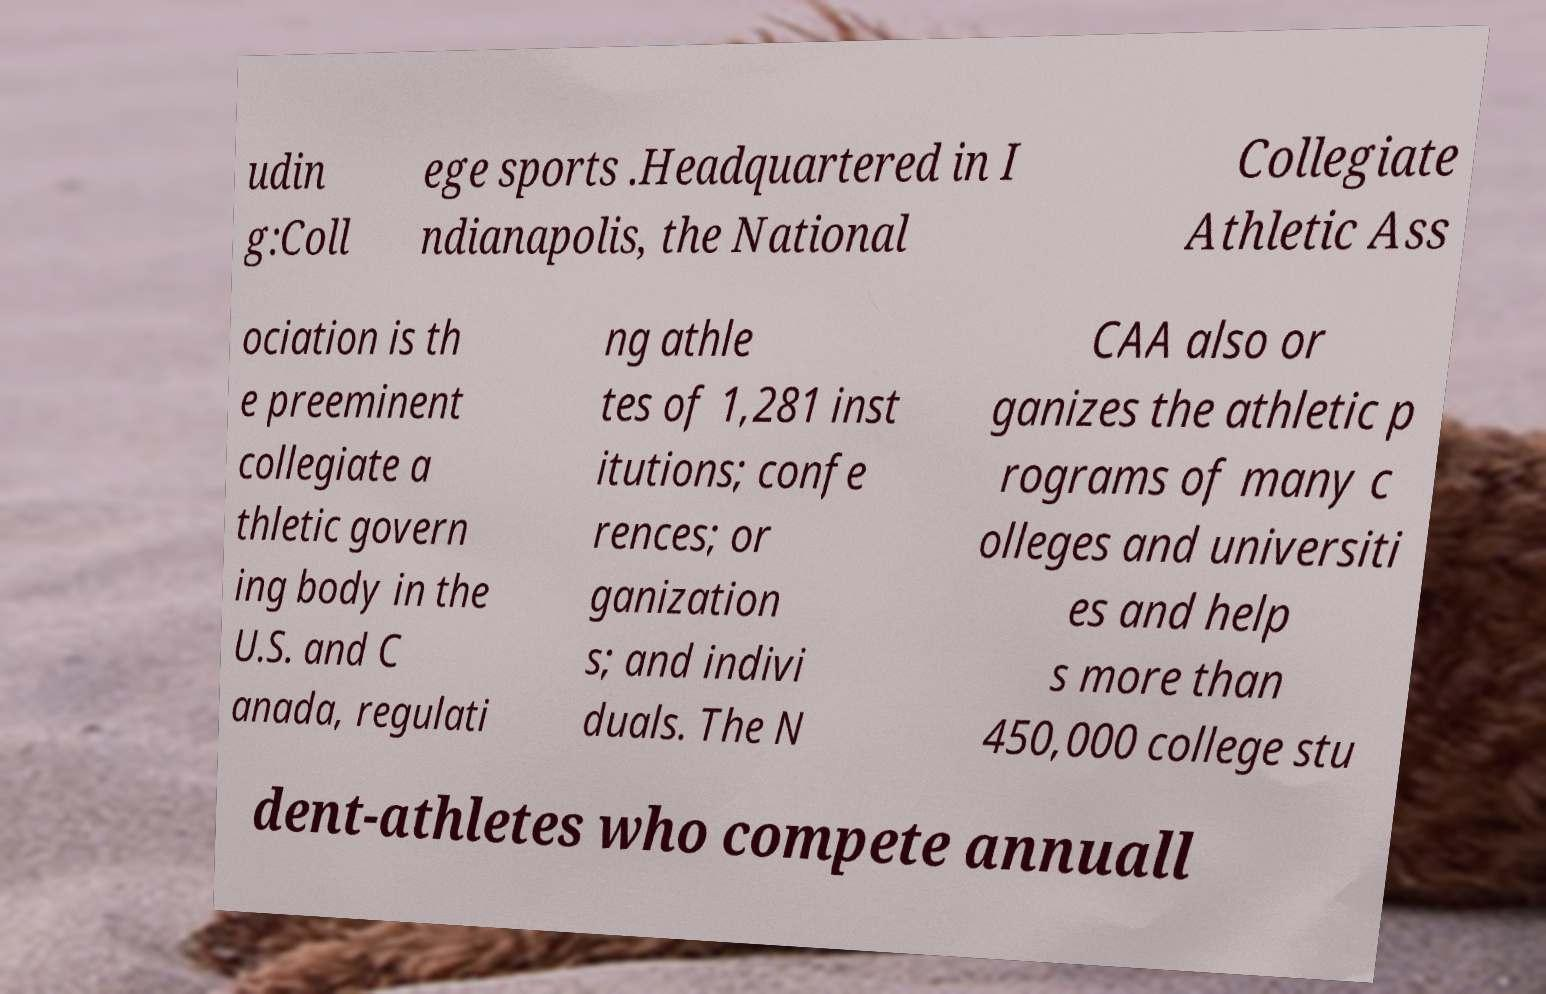Could you extract and type out the text from this image? udin g:Coll ege sports .Headquartered in I ndianapolis, the National Collegiate Athletic Ass ociation is th e preeminent collegiate a thletic govern ing body in the U.S. and C anada, regulati ng athle tes of 1,281 inst itutions; confe rences; or ganization s; and indivi duals. The N CAA also or ganizes the athletic p rograms of many c olleges and universiti es and help s more than 450,000 college stu dent-athletes who compete annuall 